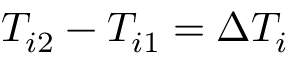<formula> <loc_0><loc_0><loc_500><loc_500>{ T _ { i 2 } - T _ { i 1 } = \Delta T _ { i } }</formula> 